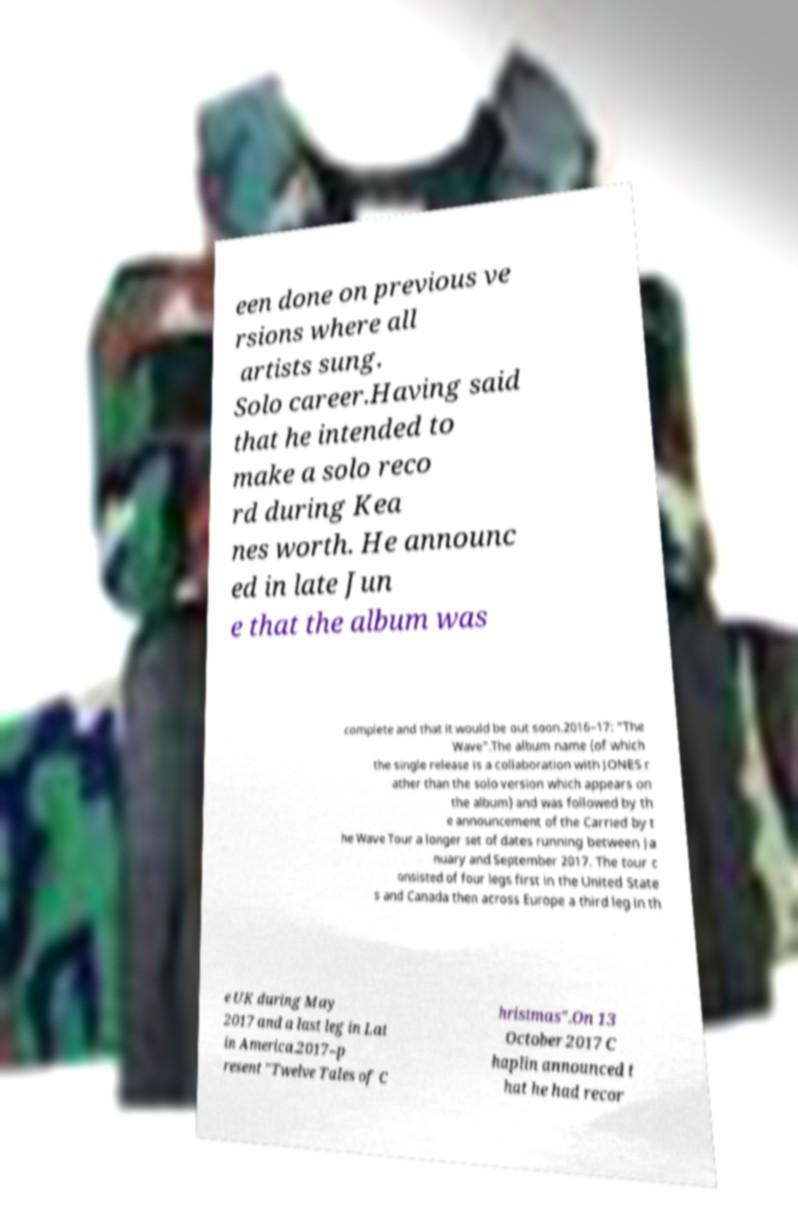For documentation purposes, I need the text within this image transcribed. Could you provide that? een done on previous ve rsions where all artists sung. Solo career.Having said that he intended to make a solo reco rd during Kea nes worth. He announc ed in late Jun e that the album was complete and that it would be out soon.2016–17: "The Wave".The album name (of which the single release is a collaboration with JONES r ather than the solo version which appears on the album) and was followed by th e announcement of the Carried by t he Wave Tour a longer set of dates running between Ja nuary and September 2017. The tour c onsisted of four legs first in the United State s and Canada then across Europe a third leg in th e UK during May 2017 and a last leg in Lat in America.2017–p resent "Twelve Tales of C hristmas".On 13 October 2017 C haplin announced t hat he had recor 